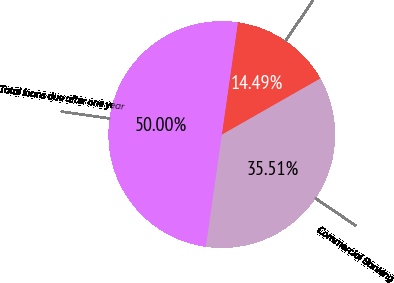Convert chart. <chart><loc_0><loc_0><loc_500><loc_500><pie_chart><fcel>Commercial Banking<fcel>Retail<fcel>Total loans due after one year<nl><fcel>35.51%<fcel>14.49%<fcel>50.0%<nl></chart> 